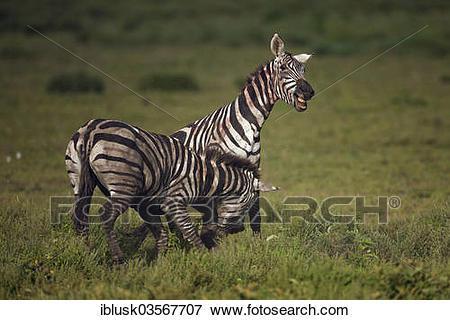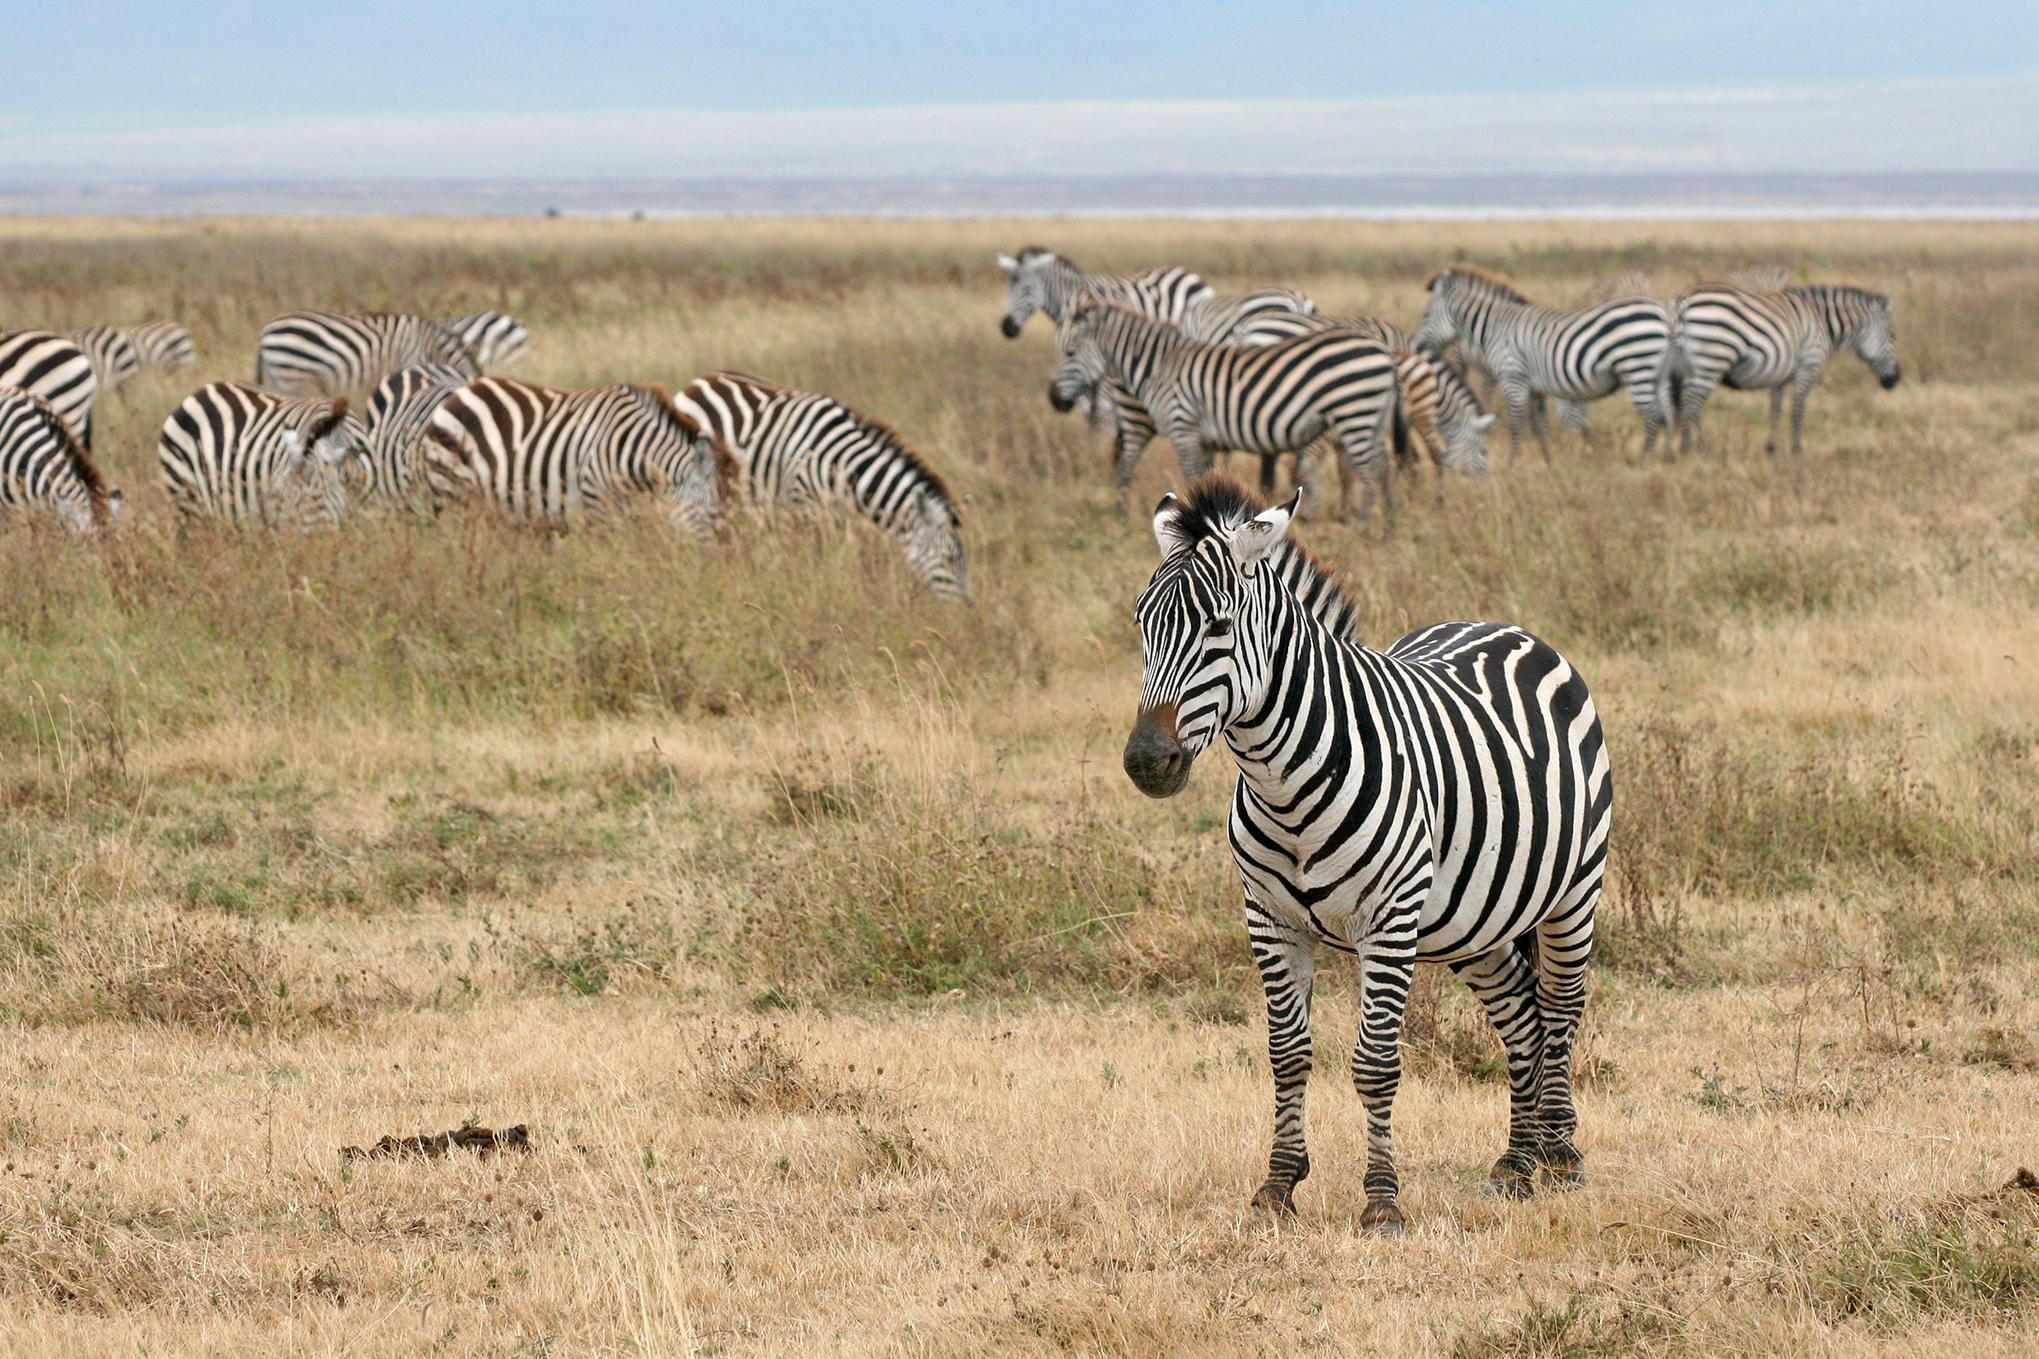The first image is the image on the left, the second image is the image on the right. For the images shown, is this caption "There is a single zebra in one image." true? Answer yes or no. No. The first image is the image on the left, the second image is the image on the right. Analyze the images presented: Is the assertion "Here we have exactly three zebras." valid? Answer yes or no. No. 